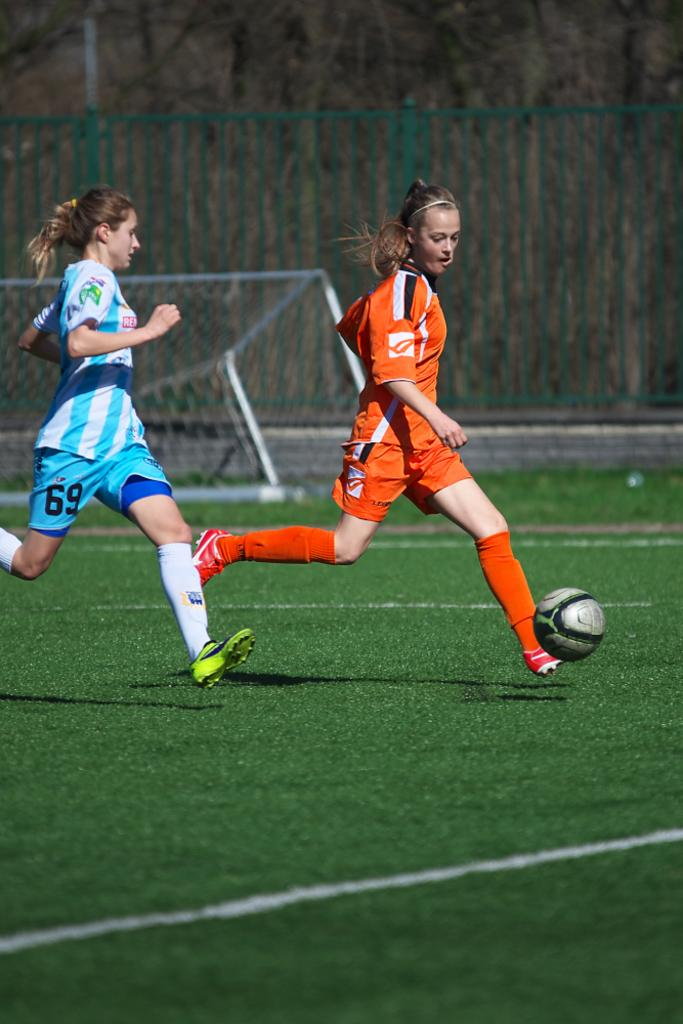<image>
Render a clear and concise summary of the photo. A girl with a Re shirt is playing soccer with a girl in orange team. 